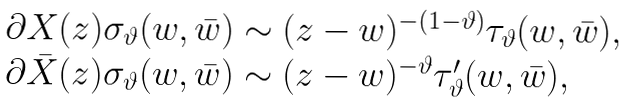Convert formula to latex. <formula><loc_0><loc_0><loc_500><loc_500>\begin{array} { l } { { \partial X ( z ) \sigma _ { \vartheta } ( w , \bar { w } ) \sim ( z - w ) ^ { - ( 1 - \vartheta ) } \tau _ { \vartheta } ( w , \bar { w } ) , } } \\ { { \partial \bar { X } ( z ) \sigma _ { \vartheta } ( w , \bar { w } ) \sim ( z - w ) ^ { - \vartheta } \tau _ { \vartheta } ^ { \prime } ( w , \bar { w } ) , } } \end{array}</formula> 